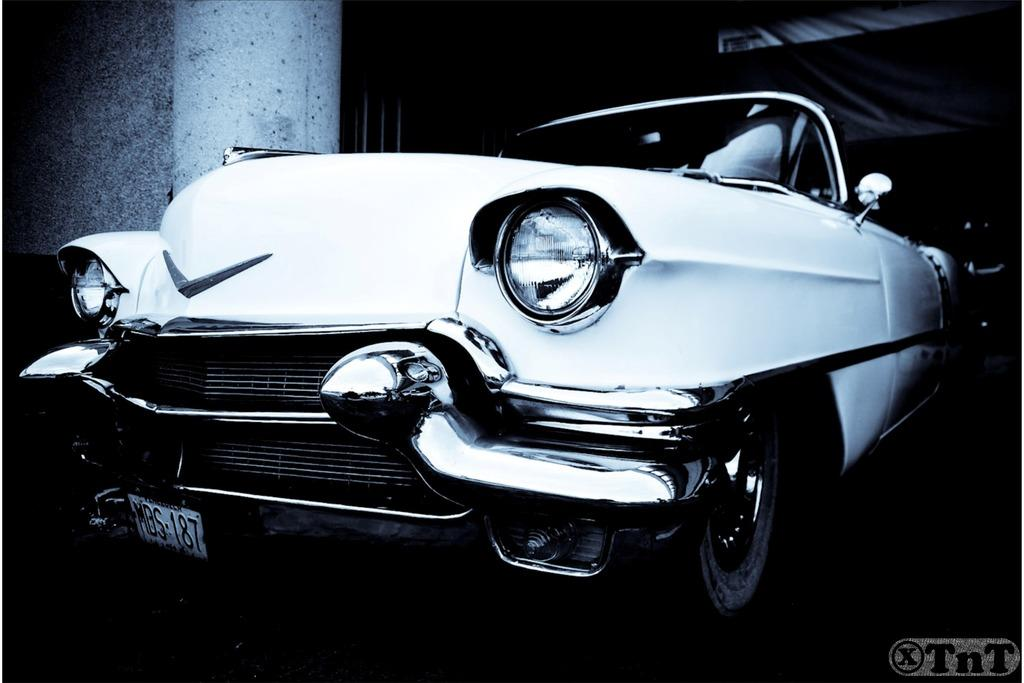What is the color scheme of the image? The image is black and white. What is the main subject in the image? There is a car in the image. What can be seen in the background of the image? There is a wall in the background of the image. Is there any text present in the image? Yes, there is some text at the bottom of the image. How many toes are visible on the car in the image? There are no toes present in the image, as it features a car and not a person or animal with toes. 